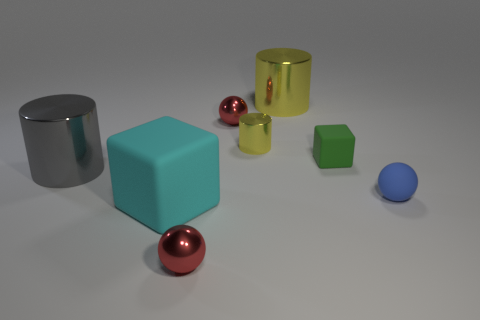How many tiny objects are brown matte cylinders or yellow metal things?
Your answer should be compact. 1. There is a small blue thing; how many big things are behind it?
Your answer should be compact. 2. Are there any other metal cylinders that have the same color as the small cylinder?
Offer a very short reply. Yes. What shape is the yellow shiny object that is the same size as the green cube?
Give a very brief answer. Cylinder. What number of brown things are either big blocks or big things?
Your answer should be compact. 0. What number of cylinders have the same size as the gray metal object?
Make the answer very short. 1. How many objects are either yellow metal things or metallic things that are to the left of the tiny blue rubber thing?
Offer a very short reply. 5. There is a sphere that is behind the tiny green cube; is it the same size as the cylinder on the left side of the big cyan cube?
Offer a terse response. No. What number of tiny green matte objects are the same shape as the cyan matte thing?
Keep it short and to the point. 1. There is a yellow thing that is made of the same material as the small cylinder; what is its shape?
Offer a terse response. Cylinder. 